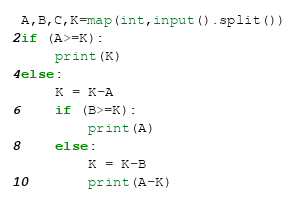Convert code to text. <code><loc_0><loc_0><loc_500><loc_500><_Python_>A,B,C,K=map(int,input().split())
if (A>=K):
	print(K)
else:
	K = K-A
	if (B>=K):
		print(A)
	else:
		K = K-B
		print(A-K)</code> 